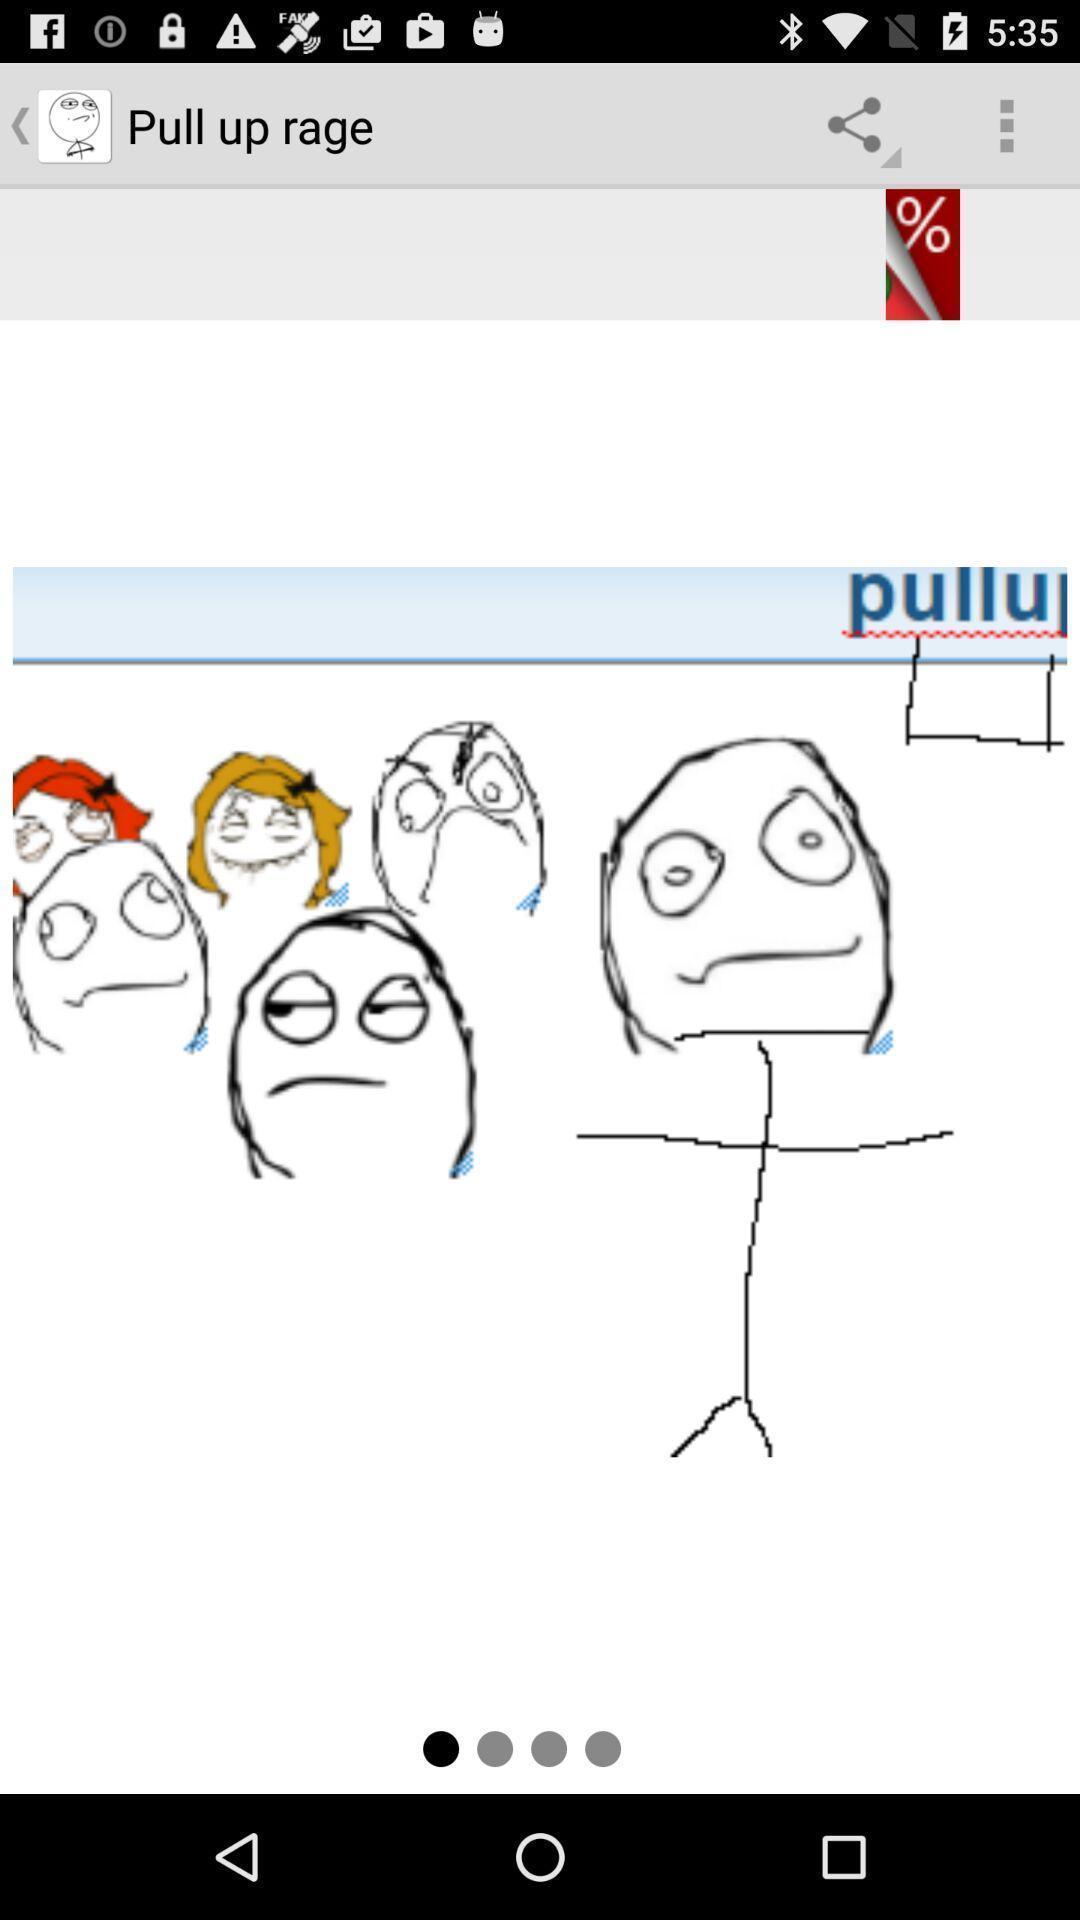Provide a detailed account of this screenshot. Welcome page displayed. 